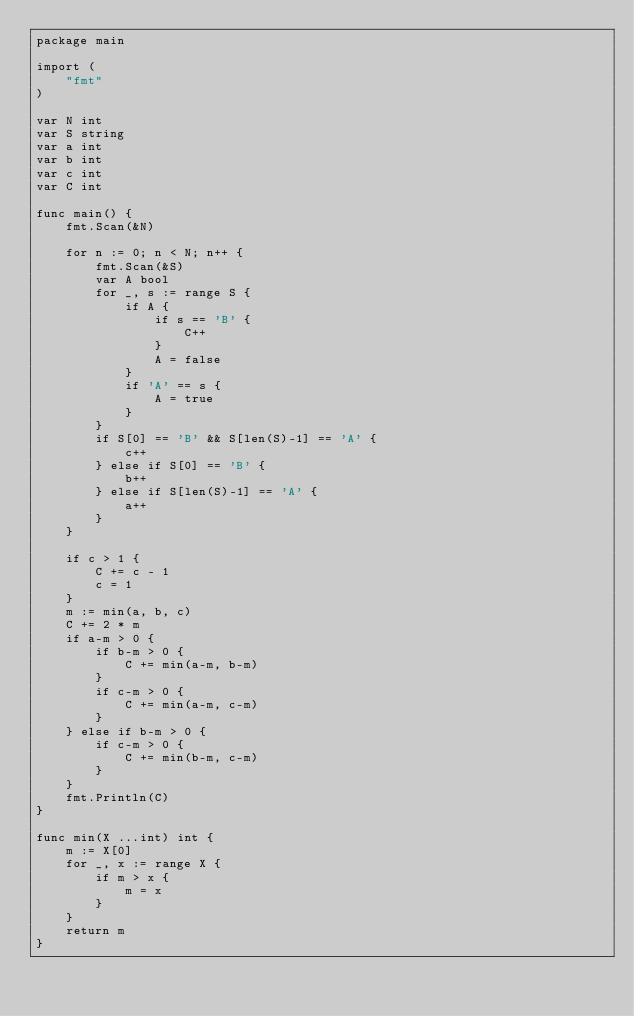<code> <loc_0><loc_0><loc_500><loc_500><_Go_>package main

import (
	"fmt"
)

var N int
var S string
var a int
var b int
var c int
var C int

func main() {
	fmt.Scan(&N)

	for n := 0; n < N; n++ {
		fmt.Scan(&S)
		var A bool
		for _, s := range S {
			if A {
				if s == 'B' {
					C++
				}
				A = false
			}
			if 'A' == s {
				A = true
			}
		}
		if S[0] == 'B' && S[len(S)-1] == 'A' {
			c++
		} else if S[0] == 'B' {
			b++
		} else if S[len(S)-1] == 'A' {
			a++
		}
	}

	if c > 1 {
		C += c - 1
		c = 1
	}
	m := min(a, b, c)
	C += 2 * m
	if a-m > 0 {
		if b-m > 0 {
			C += min(a-m, b-m)
		}
		if c-m > 0 {
			C += min(a-m, c-m)
		}
	} else if b-m > 0 {
		if c-m > 0 {
			C += min(b-m, c-m)
		}
	}
	fmt.Println(C)
}

func min(X ...int) int {
	m := X[0]
	for _, x := range X {
		if m > x {
			m = x
		}
	}
	return m
}
</code> 